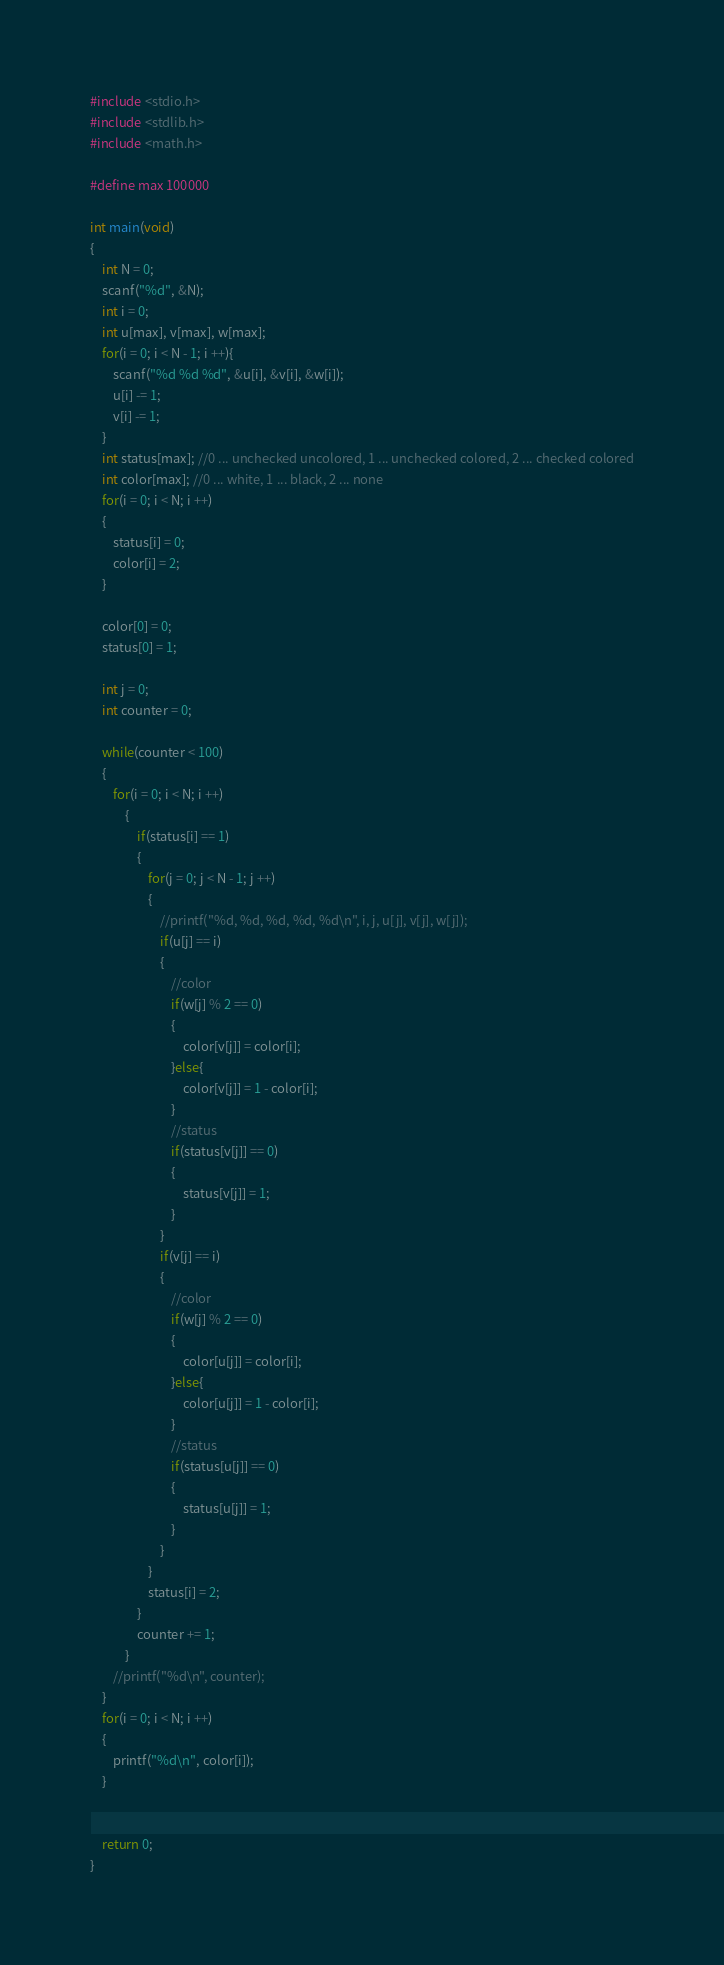Convert code to text. <code><loc_0><loc_0><loc_500><loc_500><_C_>#include <stdio.h>
#include <stdlib.h>
#include <math.h>

#define max 100000

int main(void)
{
    int N = 0;
    scanf("%d", &N);
    int i = 0;
    int u[max], v[max], w[max];
    for(i = 0; i < N - 1; i ++){
        scanf("%d %d %d", &u[i], &v[i], &w[i]);
        u[i] -= 1;
        v[i] -= 1;
    }
    int status[max]; //0 ... unchecked uncolored, 1 ... unchecked colored, 2 ... checked colored
    int color[max]; //0 ... white, 1 ... black, 2 ... none
    for(i = 0; i < N; i ++)
    {
        status[i] = 0;
        color[i] = 2;
    }
    
    color[0] = 0;
    status[0] = 1;
    
    int j = 0;
    int counter = 0;

    while(counter < 100)
    {
        for(i = 0; i < N; i ++)
            {
                if(status[i] == 1)
                {
                    for(j = 0; j < N - 1; j ++)
                    {
                        //printf("%d, %d, %d, %d, %d\n", i, j, u[j], v[j], w[j]);
                        if(u[j] == i)
                        {
                            //color
                            if(w[j] % 2 == 0)
                            {
                                color[v[j]] = color[i];
                            }else{
                                color[v[j]] = 1 - color[i];
                            }
                            //status
                            if(status[v[j]] == 0)
                            {
                                status[v[j]] = 1;
                            }
                        }
                        if(v[j] == i)
                        {
                            //color
                            if(w[j] % 2 == 0)
                            {
                                color[u[j]] = color[i];
                            }else{
                                color[u[j]] = 1 - color[i];
                            }
                            //status
                            if(status[u[j]] == 0)
                            {
                                status[u[j]] = 1;
                            }
                        }
                    }
                    status[i] = 2;
                }
                counter += 1;
            }
        //printf("%d\n", counter);
    }
    for(i = 0; i < N; i ++)
    {
        printf("%d\n", color[i]);
    }

    
    return 0;
}</code> 